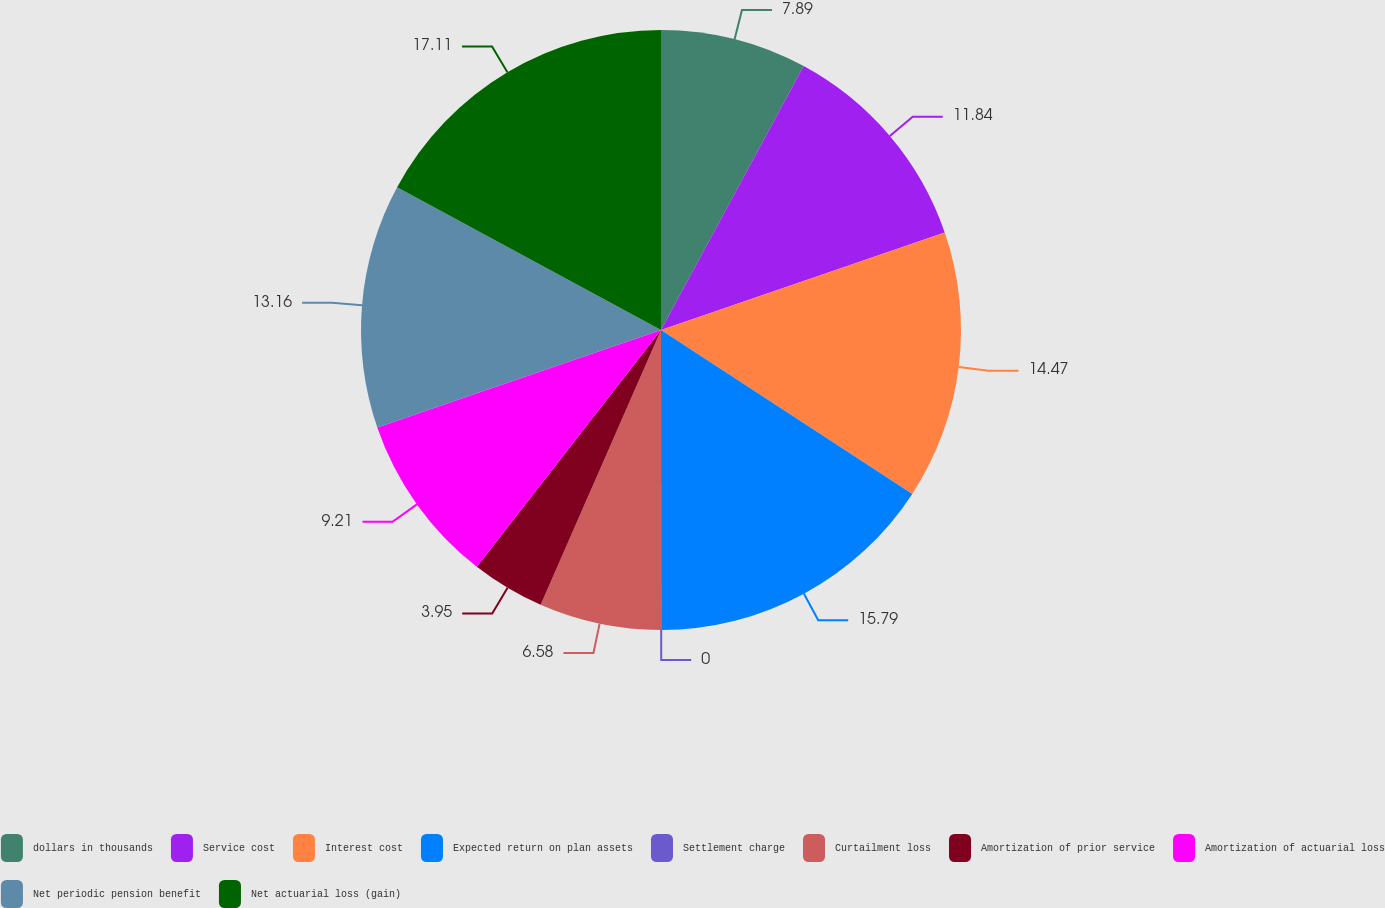<chart> <loc_0><loc_0><loc_500><loc_500><pie_chart><fcel>dollars in thousands<fcel>Service cost<fcel>Interest cost<fcel>Expected return on plan assets<fcel>Settlement charge<fcel>Curtailment loss<fcel>Amortization of prior service<fcel>Amortization of actuarial loss<fcel>Net periodic pension benefit<fcel>Net actuarial loss (gain)<nl><fcel>7.89%<fcel>11.84%<fcel>14.47%<fcel>15.79%<fcel>0.0%<fcel>6.58%<fcel>3.95%<fcel>9.21%<fcel>13.16%<fcel>17.11%<nl></chart> 